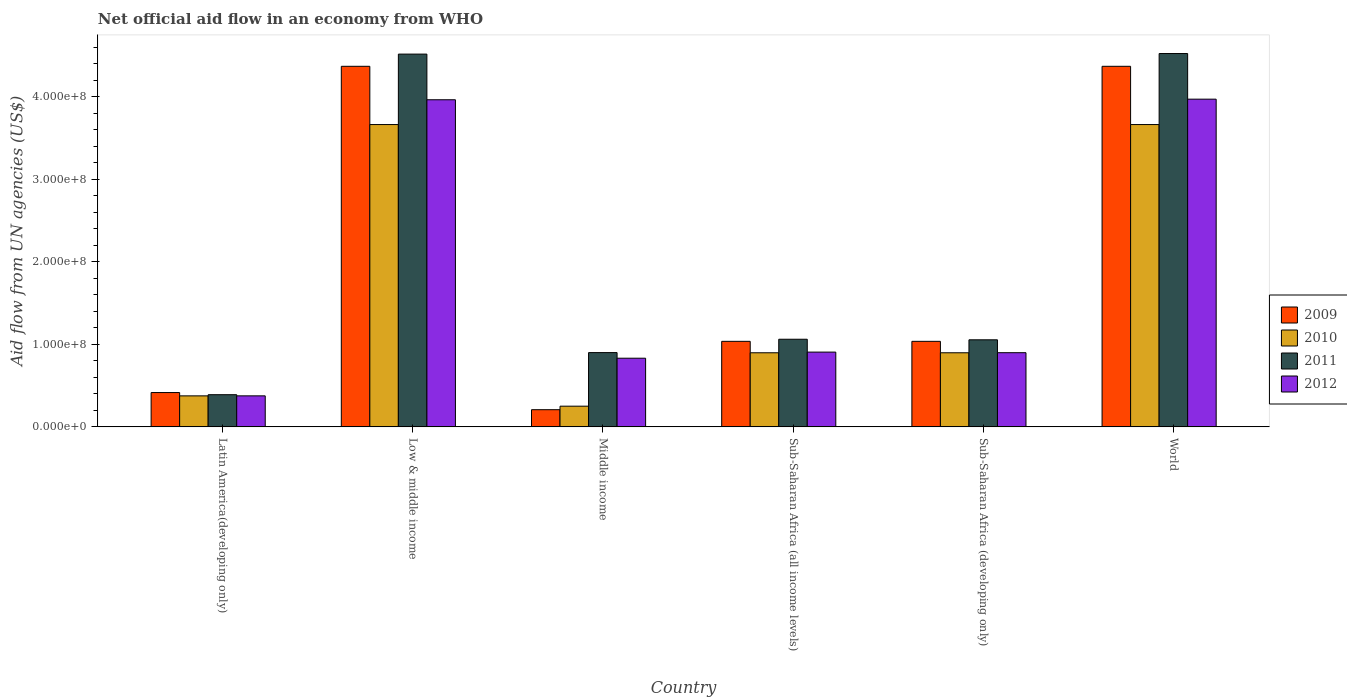How many different coloured bars are there?
Offer a very short reply. 4. Are the number of bars per tick equal to the number of legend labels?
Offer a terse response. Yes. What is the label of the 4th group of bars from the left?
Offer a very short reply. Sub-Saharan Africa (all income levels). What is the net official aid flow in 2010 in Middle income?
Keep it short and to the point. 2.51e+07. Across all countries, what is the maximum net official aid flow in 2010?
Give a very brief answer. 3.66e+08. Across all countries, what is the minimum net official aid flow in 2011?
Your answer should be very brief. 3.90e+07. In which country was the net official aid flow in 2010 minimum?
Ensure brevity in your answer.  Middle income. What is the total net official aid flow in 2012 in the graph?
Provide a short and direct response. 1.09e+09. What is the difference between the net official aid flow in 2009 in Middle income and that in World?
Provide a short and direct response. -4.16e+08. What is the difference between the net official aid flow in 2010 in Middle income and the net official aid flow in 2012 in Sub-Saharan Africa (all income levels)?
Give a very brief answer. -6.55e+07. What is the average net official aid flow in 2009 per country?
Offer a terse response. 1.91e+08. What is the difference between the net official aid flow of/in 2011 and net official aid flow of/in 2009 in Sub-Saharan Africa (developing only)?
Your response must be concise. 1.86e+06. In how many countries, is the net official aid flow in 2009 greater than 40000000 US$?
Provide a succinct answer. 5. What is the ratio of the net official aid flow in 2012 in Middle income to that in Sub-Saharan Africa (developing only)?
Offer a terse response. 0.93. Is the net official aid flow in 2012 in Middle income less than that in Sub-Saharan Africa (all income levels)?
Offer a very short reply. Yes. Is the difference between the net official aid flow in 2011 in Low & middle income and Sub-Saharan Africa (developing only) greater than the difference between the net official aid flow in 2009 in Low & middle income and Sub-Saharan Africa (developing only)?
Ensure brevity in your answer.  Yes. What is the difference between the highest and the second highest net official aid flow in 2010?
Your answer should be compact. 2.76e+08. What is the difference between the highest and the lowest net official aid flow in 2009?
Your response must be concise. 4.16e+08. What does the 1st bar from the left in Latin America(developing only) represents?
Provide a short and direct response. 2009. Are all the bars in the graph horizontal?
Ensure brevity in your answer.  No. Are the values on the major ticks of Y-axis written in scientific E-notation?
Provide a short and direct response. Yes. Does the graph contain grids?
Keep it short and to the point. No. What is the title of the graph?
Provide a short and direct response. Net official aid flow in an economy from WHO. What is the label or title of the X-axis?
Ensure brevity in your answer.  Country. What is the label or title of the Y-axis?
Provide a short and direct response. Aid flow from UN agencies (US$). What is the Aid flow from UN agencies (US$) of 2009 in Latin America(developing only)?
Ensure brevity in your answer.  4.16e+07. What is the Aid flow from UN agencies (US$) of 2010 in Latin America(developing only)?
Provide a short and direct response. 3.76e+07. What is the Aid flow from UN agencies (US$) of 2011 in Latin America(developing only)?
Offer a terse response. 3.90e+07. What is the Aid flow from UN agencies (US$) of 2012 in Latin America(developing only)?
Your response must be concise. 3.76e+07. What is the Aid flow from UN agencies (US$) of 2009 in Low & middle income?
Offer a very short reply. 4.37e+08. What is the Aid flow from UN agencies (US$) of 2010 in Low & middle income?
Give a very brief answer. 3.66e+08. What is the Aid flow from UN agencies (US$) in 2011 in Low & middle income?
Give a very brief answer. 4.52e+08. What is the Aid flow from UN agencies (US$) of 2012 in Low & middle income?
Provide a short and direct response. 3.96e+08. What is the Aid flow from UN agencies (US$) of 2009 in Middle income?
Provide a short and direct response. 2.08e+07. What is the Aid flow from UN agencies (US$) of 2010 in Middle income?
Your response must be concise. 2.51e+07. What is the Aid flow from UN agencies (US$) in 2011 in Middle income?
Offer a very short reply. 9.00e+07. What is the Aid flow from UN agencies (US$) of 2012 in Middle income?
Make the answer very short. 8.32e+07. What is the Aid flow from UN agencies (US$) in 2009 in Sub-Saharan Africa (all income levels)?
Make the answer very short. 1.04e+08. What is the Aid flow from UN agencies (US$) of 2010 in Sub-Saharan Africa (all income levels)?
Make the answer very short. 8.98e+07. What is the Aid flow from UN agencies (US$) of 2011 in Sub-Saharan Africa (all income levels)?
Your answer should be compact. 1.06e+08. What is the Aid flow from UN agencies (US$) in 2012 in Sub-Saharan Africa (all income levels)?
Your answer should be compact. 9.06e+07. What is the Aid flow from UN agencies (US$) in 2009 in Sub-Saharan Africa (developing only)?
Your response must be concise. 1.04e+08. What is the Aid flow from UN agencies (US$) of 2010 in Sub-Saharan Africa (developing only)?
Provide a short and direct response. 8.98e+07. What is the Aid flow from UN agencies (US$) of 2011 in Sub-Saharan Africa (developing only)?
Your answer should be compact. 1.05e+08. What is the Aid flow from UN agencies (US$) of 2012 in Sub-Saharan Africa (developing only)?
Give a very brief answer. 8.98e+07. What is the Aid flow from UN agencies (US$) in 2009 in World?
Your response must be concise. 4.37e+08. What is the Aid flow from UN agencies (US$) of 2010 in World?
Keep it short and to the point. 3.66e+08. What is the Aid flow from UN agencies (US$) in 2011 in World?
Ensure brevity in your answer.  4.52e+08. What is the Aid flow from UN agencies (US$) in 2012 in World?
Give a very brief answer. 3.97e+08. Across all countries, what is the maximum Aid flow from UN agencies (US$) of 2009?
Provide a short and direct response. 4.37e+08. Across all countries, what is the maximum Aid flow from UN agencies (US$) of 2010?
Provide a short and direct response. 3.66e+08. Across all countries, what is the maximum Aid flow from UN agencies (US$) of 2011?
Keep it short and to the point. 4.52e+08. Across all countries, what is the maximum Aid flow from UN agencies (US$) of 2012?
Give a very brief answer. 3.97e+08. Across all countries, what is the minimum Aid flow from UN agencies (US$) in 2009?
Provide a succinct answer. 2.08e+07. Across all countries, what is the minimum Aid flow from UN agencies (US$) of 2010?
Your response must be concise. 2.51e+07. Across all countries, what is the minimum Aid flow from UN agencies (US$) of 2011?
Your answer should be very brief. 3.90e+07. Across all countries, what is the minimum Aid flow from UN agencies (US$) in 2012?
Offer a very short reply. 3.76e+07. What is the total Aid flow from UN agencies (US$) of 2009 in the graph?
Ensure brevity in your answer.  1.14e+09. What is the total Aid flow from UN agencies (US$) in 2010 in the graph?
Provide a short and direct response. 9.75e+08. What is the total Aid flow from UN agencies (US$) of 2011 in the graph?
Offer a very short reply. 1.24e+09. What is the total Aid flow from UN agencies (US$) of 2012 in the graph?
Your response must be concise. 1.09e+09. What is the difference between the Aid flow from UN agencies (US$) of 2009 in Latin America(developing only) and that in Low & middle income?
Provide a short and direct response. -3.95e+08. What is the difference between the Aid flow from UN agencies (US$) of 2010 in Latin America(developing only) and that in Low & middle income?
Your response must be concise. -3.29e+08. What is the difference between the Aid flow from UN agencies (US$) in 2011 in Latin America(developing only) and that in Low & middle income?
Your answer should be compact. -4.13e+08. What is the difference between the Aid flow from UN agencies (US$) in 2012 in Latin America(developing only) and that in Low & middle income?
Offer a terse response. -3.59e+08. What is the difference between the Aid flow from UN agencies (US$) in 2009 in Latin America(developing only) and that in Middle income?
Your answer should be very brief. 2.08e+07. What is the difference between the Aid flow from UN agencies (US$) in 2010 in Latin America(developing only) and that in Middle income?
Offer a terse response. 1.25e+07. What is the difference between the Aid flow from UN agencies (US$) in 2011 in Latin America(developing only) and that in Middle income?
Provide a succinct answer. -5.10e+07. What is the difference between the Aid flow from UN agencies (US$) of 2012 in Latin America(developing only) and that in Middle income?
Your answer should be very brief. -4.56e+07. What is the difference between the Aid flow from UN agencies (US$) of 2009 in Latin America(developing only) and that in Sub-Saharan Africa (all income levels)?
Provide a short and direct response. -6.20e+07. What is the difference between the Aid flow from UN agencies (US$) in 2010 in Latin America(developing only) and that in Sub-Saharan Africa (all income levels)?
Make the answer very short. -5.22e+07. What is the difference between the Aid flow from UN agencies (US$) in 2011 in Latin America(developing only) and that in Sub-Saharan Africa (all income levels)?
Keep it short and to the point. -6.72e+07. What is the difference between the Aid flow from UN agencies (US$) in 2012 in Latin America(developing only) and that in Sub-Saharan Africa (all income levels)?
Keep it short and to the point. -5.30e+07. What is the difference between the Aid flow from UN agencies (US$) in 2009 in Latin America(developing only) and that in Sub-Saharan Africa (developing only)?
Provide a short and direct response. -6.20e+07. What is the difference between the Aid flow from UN agencies (US$) in 2010 in Latin America(developing only) and that in Sub-Saharan Africa (developing only)?
Provide a succinct answer. -5.22e+07. What is the difference between the Aid flow from UN agencies (US$) in 2011 in Latin America(developing only) and that in Sub-Saharan Africa (developing only)?
Make the answer very short. -6.65e+07. What is the difference between the Aid flow from UN agencies (US$) of 2012 in Latin America(developing only) and that in Sub-Saharan Africa (developing only)?
Provide a succinct answer. -5.23e+07. What is the difference between the Aid flow from UN agencies (US$) in 2009 in Latin America(developing only) and that in World?
Provide a succinct answer. -3.95e+08. What is the difference between the Aid flow from UN agencies (US$) of 2010 in Latin America(developing only) and that in World?
Your response must be concise. -3.29e+08. What is the difference between the Aid flow from UN agencies (US$) in 2011 in Latin America(developing only) and that in World?
Offer a very short reply. -4.13e+08. What is the difference between the Aid flow from UN agencies (US$) in 2012 in Latin America(developing only) and that in World?
Your answer should be very brief. -3.59e+08. What is the difference between the Aid flow from UN agencies (US$) of 2009 in Low & middle income and that in Middle income?
Offer a terse response. 4.16e+08. What is the difference between the Aid flow from UN agencies (US$) in 2010 in Low & middle income and that in Middle income?
Your response must be concise. 3.41e+08. What is the difference between the Aid flow from UN agencies (US$) of 2011 in Low & middle income and that in Middle income?
Provide a short and direct response. 3.62e+08. What is the difference between the Aid flow from UN agencies (US$) of 2012 in Low & middle income and that in Middle income?
Ensure brevity in your answer.  3.13e+08. What is the difference between the Aid flow from UN agencies (US$) in 2009 in Low & middle income and that in Sub-Saharan Africa (all income levels)?
Your answer should be very brief. 3.33e+08. What is the difference between the Aid flow from UN agencies (US$) in 2010 in Low & middle income and that in Sub-Saharan Africa (all income levels)?
Give a very brief answer. 2.76e+08. What is the difference between the Aid flow from UN agencies (US$) of 2011 in Low & middle income and that in Sub-Saharan Africa (all income levels)?
Ensure brevity in your answer.  3.45e+08. What is the difference between the Aid flow from UN agencies (US$) of 2012 in Low & middle income and that in Sub-Saharan Africa (all income levels)?
Give a very brief answer. 3.06e+08. What is the difference between the Aid flow from UN agencies (US$) in 2009 in Low & middle income and that in Sub-Saharan Africa (developing only)?
Provide a short and direct response. 3.33e+08. What is the difference between the Aid flow from UN agencies (US$) in 2010 in Low & middle income and that in Sub-Saharan Africa (developing only)?
Make the answer very short. 2.76e+08. What is the difference between the Aid flow from UN agencies (US$) of 2011 in Low & middle income and that in Sub-Saharan Africa (developing only)?
Provide a succinct answer. 3.46e+08. What is the difference between the Aid flow from UN agencies (US$) in 2012 in Low & middle income and that in Sub-Saharan Africa (developing only)?
Your response must be concise. 3.06e+08. What is the difference between the Aid flow from UN agencies (US$) of 2011 in Low & middle income and that in World?
Your response must be concise. -6.70e+05. What is the difference between the Aid flow from UN agencies (US$) in 2012 in Low & middle income and that in World?
Give a very brief answer. -7.20e+05. What is the difference between the Aid flow from UN agencies (US$) of 2009 in Middle income and that in Sub-Saharan Africa (all income levels)?
Your answer should be very brief. -8.28e+07. What is the difference between the Aid flow from UN agencies (US$) in 2010 in Middle income and that in Sub-Saharan Africa (all income levels)?
Make the answer very short. -6.47e+07. What is the difference between the Aid flow from UN agencies (US$) in 2011 in Middle income and that in Sub-Saharan Africa (all income levels)?
Your response must be concise. -1.62e+07. What is the difference between the Aid flow from UN agencies (US$) in 2012 in Middle income and that in Sub-Saharan Africa (all income levels)?
Give a very brief answer. -7.39e+06. What is the difference between the Aid flow from UN agencies (US$) in 2009 in Middle income and that in Sub-Saharan Africa (developing only)?
Provide a short and direct response. -8.28e+07. What is the difference between the Aid flow from UN agencies (US$) of 2010 in Middle income and that in Sub-Saharan Africa (developing only)?
Keep it short and to the point. -6.47e+07. What is the difference between the Aid flow from UN agencies (US$) of 2011 in Middle income and that in Sub-Saharan Africa (developing only)?
Provide a short and direct response. -1.55e+07. What is the difference between the Aid flow from UN agencies (US$) in 2012 in Middle income and that in Sub-Saharan Africa (developing only)?
Provide a short and direct response. -6.67e+06. What is the difference between the Aid flow from UN agencies (US$) in 2009 in Middle income and that in World?
Keep it short and to the point. -4.16e+08. What is the difference between the Aid flow from UN agencies (US$) in 2010 in Middle income and that in World?
Provide a short and direct response. -3.41e+08. What is the difference between the Aid flow from UN agencies (US$) of 2011 in Middle income and that in World?
Give a very brief answer. -3.62e+08. What is the difference between the Aid flow from UN agencies (US$) of 2012 in Middle income and that in World?
Your response must be concise. -3.14e+08. What is the difference between the Aid flow from UN agencies (US$) in 2009 in Sub-Saharan Africa (all income levels) and that in Sub-Saharan Africa (developing only)?
Ensure brevity in your answer.  0. What is the difference between the Aid flow from UN agencies (US$) in 2010 in Sub-Saharan Africa (all income levels) and that in Sub-Saharan Africa (developing only)?
Provide a succinct answer. 0. What is the difference between the Aid flow from UN agencies (US$) of 2011 in Sub-Saharan Africa (all income levels) and that in Sub-Saharan Africa (developing only)?
Ensure brevity in your answer.  6.70e+05. What is the difference between the Aid flow from UN agencies (US$) in 2012 in Sub-Saharan Africa (all income levels) and that in Sub-Saharan Africa (developing only)?
Offer a very short reply. 7.20e+05. What is the difference between the Aid flow from UN agencies (US$) of 2009 in Sub-Saharan Africa (all income levels) and that in World?
Your answer should be compact. -3.33e+08. What is the difference between the Aid flow from UN agencies (US$) in 2010 in Sub-Saharan Africa (all income levels) and that in World?
Offer a terse response. -2.76e+08. What is the difference between the Aid flow from UN agencies (US$) in 2011 in Sub-Saharan Africa (all income levels) and that in World?
Your response must be concise. -3.46e+08. What is the difference between the Aid flow from UN agencies (US$) in 2012 in Sub-Saharan Africa (all income levels) and that in World?
Ensure brevity in your answer.  -3.06e+08. What is the difference between the Aid flow from UN agencies (US$) of 2009 in Sub-Saharan Africa (developing only) and that in World?
Your answer should be very brief. -3.33e+08. What is the difference between the Aid flow from UN agencies (US$) of 2010 in Sub-Saharan Africa (developing only) and that in World?
Keep it short and to the point. -2.76e+08. What is the difference between the Aid flow from UN agencies (US$) of 2011 in Sub-Saharan Africa (developing only) and that in World?
Make the answer very short. -3.47e+08. What is the difference between the Aid flow from UN agencies (US$) of 2012 in Sub-Saharan Africa (developing only) and that in World?
Your answer should be very brief. -3.07e+08. What is the difference between the Aid flow from UN agencies (US$) in 2009 in Latin America(developing only) and the Aid flow from UN agencies (US$) in 2010 in Low & middle income?
Provide a succinct answer. -3.25e+08. What is the difference between the Aid flow from UN agencies (US$) in 2009 in Latin America(developing only) and the Aid flow from UN agencies (US$) in 2011 in Low & middle income?
Your response must be concise. -4.10e+08. What is the difference between the Aid flow from UN agencies (US$) in 2009 in Latin America(developing only) and the Aid flow from UN agencies (US$) in 2012 in Low & middle income?
Your response must be concise. -3.55e+08. What is the difference between the Aid flow from UN agencies (US$) in 2010 in Latin America(developing only) and the Aid flow from UN agencies (US$) in 2011 in Low & middle income?
Offer a very short reply. -4.14e+08. What is the difference between the Aid flow from UN agencies (US$) in 2010 in Latin America(developing only) and the Aid flow from UN agencies (US$) in 2012 in Low & middle income?
Offer a very short reply. -3.59e+08. What is the difference between the Aid flow from UN agencies (US$) of 2011 in Latin America(developing only) and the Aid flow from UN agencies (US$) of 2012 in Low & middle income?
Ensure brevity in your answer.  -3.57e+08. What is the difference between the Aid flow from UN agencies (US$) in 2009 in Latin America(developing only) and the Aid flow from UN agencies (US$) in 2010 in Middle income?
Provide a succinct answer. 1.65e+07. What is the difference between the Aid flow from UN agencies (US$) of 2009 in Latin America(developing only) and the Aid flow from UN agencies (US$) of 2011 in Middle income?
Your answer should be compact. -4.84e+07. What is the difference between the Aid flow from UN agencies (US$) in 2009 in Latin America(developing only) and the Aid flow from UN agencies (US$) in 2012 in Middle income?
Offer a very short reply. -4.16e+07. What is the difference between the Aid flow from UN agencies (US$) in 2010 in Latin America(developing only) and the Aid flow from UN agencies (US$) in 2011 in Middle income?
Your answer should be very brief. -5.24e+07. What is the difference between the Aid flow from UN agencies (US$) in 2010 in Latin America(developing only) and the Aid flow from UN agencies (US$) in 2012 in Middle income?
Keep it short and to the point. -4.56e+07. What is the difference between the Aid flow from UN agencies (US$) of 2011 in Latin America(developing only) and the Aid flow from UN agencies (US$) of 2012 in Middle income?
Offer a terse response. -4.42e+07. What is the difference between the Aid flow from UN agencies (US$) of 2009 in Latin America(developing only) and the Aid flow from UN agencies (US$) of 2010 in Sub-Saharan Africa (all income levels)?
Make the answer very short. -4.82e+07. What is the difference between the Aid flow from UN agencies (US$) of 2009 in Latin America(developing only) and the Aid flow from UN agencies (US$) of 2011 in Sub-Saharan Africa (all income levels)?
Your answer should be very brief. -6.46e+07. What is the difference between the Aid flow from UN agencies (US$) of 2009 in Latin America(developing only) and the Aid flow from UN agencies (US$) of 2012 in Sub-Saharan Africa (all income levels)?
Give a very brief answer. -4.90e+07. What is the difference between the Aid flow from UN agencies (US$) in 2010 in Latin America(developing only) and the Aid flow from UN agencies (US$) in 2011 in Sub-Saharan Africa (all income levels)?
Your answer should be compact. -6.86e+07. What is the difference between the Aid flow from UN agencies (US$) of 2010 in Latin America(developing only) and the Aid flow from UN agencies (US$) of 2012 in Sub-Saharan Africa (all income levels)?
Offer a very short reply. -5.30e+07. What is the difference between the Aid flow from UN agencies (US$) of 2011 in Latin America(developing only) and the Aid flow from UN agencies (US$) of 2012 in Sub-Saharan Africa (all income levels)?
Make the answer very short. -5.16e+07. What is the difference between the Aid flow from UN agencies (US$) in 2009 in Latin America(developing only) and the Aid flow from UN agencies (US$) in 2010 in Sub-Saharan Africa (developing only)?
Your response must be concise. -4.82e+07. What is the difference between the Aid flow from UN agencies (US$) in 2009 in Latin America(developing only) and the Aid flow from UN agencies (US$) in 2011 in Sub-Saharan Africa (developing only)?
Give a very brief answer. -6.39e+07. What is the difference between the Aid flow from UN agencies (US$) in 2009 in Latin America(developing only) and the Aid flow from UN agencies (US$) in 2012 in Sub-Saharan Africa (developing only)?
Provide a short and direct response. -4.83e+07. What is the difference between the Aid flow from UN agencies (US$) of 2010 in Latin America(developing only) and the Aid flow from UN agencies (US$) of 2011 in Sub-Saharan Africa (developing only)?
Make the answer very short. -6.79e+07. What is the difference between the Aid flow from UN agencies (US$) of 2010 in Latin America(developing only) and the Aid flow from UN agencies (US$) of 2012 in Sub-Saharan Africa (developing only)?
Ensure brevity in your answer.  -5.23e+07. What is the difference between the Aid flow from UN agencies (US$) of 2011 in Latin America(developing only) and the Aid flow from UN agencies (US$) of 2012 in Sub-Saharan Africa (developing only)?
Offer a terse response. -5.09e+07. What is the difference between the Aid flow from UN agencies (US$) in 2009 in Latin America(developing only) and the Aid flow from UN agencies (US$) in 2010 in World?
Provide a succinct answer. -3.25e+08. What is the difference between the Aid flow from UN agencies (US$) of 2009 in Latin America(developing only) and the Aid flow from UN agencies (US$) of 2011 in World?
Ensure brevity in your answer.  -4.11e+08. What is the difference between the Aid flow from UN agencies (US$) of 2009 in Latin America(developing only) and the Aid flow from UN agencies (US$) of 2012 in World?
Ensure brevity in your answer.  -3.55e+08. What is the difference between the Aid flow from UN agencies (US$) of 2010 in Latin America(developing only) and the Aid flow from UN agencies (US$) of 2011 in World?
Your answer should be compact. -4.15e+08. What is the difference between the Aid flow from UN agencies (US$) of 2010 in Latin America(developing only) and the Aid flow from UN agencies (US$) of 2012 in World?
Your answer should be very brief. -3.59e+08. What is the difference between the Aid flow from UN agencies (US$) in 2011 in Latin America(developing only) and the Aid flow from UN agencies (US$) in 2012 in World?
Offer a very short reply. -3.58e+08. What is the difference between the Aid flow from UN agencies (US$) of 2009 in Low & middle income and the Aid flow from UN agencies (US$) of 2010 in Middle income?
Give a very brief answer. 4.12e+08. What is the difference between the Aid flow from UN agencies (US$) of 2009 in Low & middle income and the Aid flow from UN agencies (US$) of 2011 in Middle income?
Provide a short and direct response. 3.47e+08. What is the difference between the Aid flow from UN agencies (US$) in 2009 in Low & middle income and the Aid flow from UN agencies (US$) in 2012 in Middle income?
Ensure brevity in your answer.  3.54e+08. What is the difference between the Aid flow from UN agencies (US$) of 2010 in Low & middle income and the Aid flow from UN agencies (US$) of 2011 in Middle income?
Ensure brevity in your answer.  2.76e+08. What is the difference between the Aid flow from UN agencies (US$) in 2010 in Low & middle income and the Aid flow from UN agencies (US$) in 2012 in Middle income?
Give a very brief answer. 2.83e+08. What is the difference between the Aid flow from UN agencies (US$) of 2011 in Low & middle income and the Aid flow from UN agencies (US$) of 2012 in Middle income?
Your answer should be very brief. 3.68e+08. What is the difference between the Aid flow from UN agencies (US$) of 2009 in Low & middle income and the Aid flow from UN agencies (US$) of 2010 in Sub-Saharan Africa (all income levels)?
Provide a succinct answer. 3.47e+08. What is the difference between the Aid flow from UN agencies (US$) of 2009 in Low & middle income and the Aid flow from UN agencies (US$) of 2011 in Sub-Saharan Africa (all income levels)?
Offer a terse response. 3.31e+08. What is the difference between the Aid flow from UN agencies (US$) in 2009 in Low & middle income and the Aid flow from UN agencies (US$) in 2012 in Sub-Saharan Africa (all income levels)?
Keep it short and to the point. 3.46e+08. What is the difference between the Aid flow from UN agencies (US$) of 2010 in Low & middle income and the Aid flow from UN agencies (US$) of 2011 in Sub-Saharan Africa (all income levels)?
Provide a succinct answer. 2.60e+08. What is the difference between the Aid flow from UN agencies (US$) in 2010 in Low & middle income and the Aid flow from UN agencies (US$) in 2012 in Sub-Saharan Africa (all income levels)?
Ensure brevity in your answer.  2.76e+08. What is the difference between the Aid flow from UN agencies (US$) of 2011 in Low & middle income and the Aid flow from UN agencies (US$) of 2012 in Sub-Saharan Africa (all income levels)?
Offer a very short reply. 3.61e+08. What is the difference between the Aid flow from UN agencies (US$) of 2009 in Low & middle income and the Aid flow from UN agencies (US$) of 2010 in Sub-Saharan Africa (developing only)?
Give a very brief answer. 3.47e+08. What is the difference between the Aid flow from UN agencies (US$) of 2009 in Low & middle income and the Aid flow from UN agencies (US$) of 2011 in Sub-Saharan Africa (developing only)?
Keep it short and to the point. 3.31e+08. What is the difference between the Aid flow from UN agencies (US$) of 2009 in Low & middle income and the Aid flow from UN agencies (US$) of 2012 in Sub-Saharan Africa (developing only)?
Offer a terse response. 3.47e+08. What is the difference between the Aid flow from UN agencies (US$) in 2010 in Low & middle income and the Aid flow from UN agencies (US$) in 2011 in Sub-Saharan Africa (developing only)?
Make the answer very short. 2.61e+08. What is the difference between the Aid flow from UN agencies (US$) of 2010 in Low & middle income and the Aid flow from UN agencies (US$) of 2012 in Sub-Saharan Africa (developing only)?
Ensure brevity in your answer.  2.76e+08. What is the difference between the Aid flow from UN agencies (US$) of 2011 in Low & middle income and the Aid flow from UN agencies (US$) of 2012 in Sub-Saharan Africa (developing only)?
Provide a short and direct response. 3.62e+08. What is the difference between the Aid flow from UN agencies (US$) of 2009 in Low & middle income and the Aid flow from UN agencies (US$) of 2010 in World?
Make the answer very short. 7.06e+07. What is the difference between the Aid flow from UN agencies (US$) of 2009 in Low & middle income and the Aid flow from UN agencies (US$) of 2011 in World?
Give a very brief answer. -1.55e+07. What is the difference between the Aid flow from UN agencies (US$) of 2009 in Low & middle income and the Aid flow from UN agencies (US$) of 2012 in World?
Your answer should be compact. 3.98e+07. What is the difference between the Aid flow from UN agencies (US$) in 2010 in Low & middle income and the Aid flow from UN agencies (US$) in 2011 in World?
Offer a very short reply. -8.60e+07. What is the difference between the Aid flow from UN agencies (US$) in 2010 in Low & middle income and the Aid flow from UN agencies (US$) in 2012 in World?
Your answer should be very brief. -3.08e+07. What is the difference between the Aid flow from UN agencies (US$) in 2011 in Low & middle income and the Aid flow from UN agencies (US$) in 2012 in World?
Keep it short and to the point. 5.46e+07. What is the difference between the Aid flow from UN agencies (US$) in 2009 in Middle income and the Aid flow from UN agencies (US$) in 2010 in Sub-Saharan Africa (all income levels)?
Your response must be concise. -6.90e+07. What is the difference between the Aid flow from UN agencies (US$) of 2009 in Middle income and the Aid flow from UN agencies (US$) of 2011 in Sub-Saharan Africa (all income levels)?
Make the answer very short. -8.54e+07. What is the difference between the Aid flow from UN agencies (US$) in 2009 in Middle income and the Aid flow from UN agencies (US$) in 2012 in Sub-Saharan Africa (all income levels)?
Give a very brief answer. -6.98e+07. What is the difference between the Aid flow from UN agencies (US$) in 2010 in Middle income and the Aid flow from UN agencies (US$) in 2011 in Sub-Saharan Africa (all income levels)?
Provide a short and direct response. -8.11e+07. What is the difference between the Aid flow from UN agencies (US$) in 2010 in Middle income and the Aid flow from UN agencies (US$) in 2012 in Sub-Saharan Africa (all income levels)?
Give a very brief answer. -6.55e+07. What is the difference between the Aid flow from UN agencies (US$) of 2011 in Middle income and the Aid flow from UN agencies (US$) of 2012 in Sub-Saharan Africa (all income levels)?
Your answer should be compact. -5.90e+05. What is the difference between the Aid flow from UN agencies (US$) in 2009 in Middle income and the Aid flow from UN agencies (US$) in 2010 in Sub-Saharan Africa (developing only)?
Keep it short and to the point. -6.90e+07. What is the difference between the Aid flow from UN agencies (US$) in 2009 in Middle income and the Aid flow from UN agencies (US$) in 2011 in Sub-Saharan Africa (developing only)?
Provide a succinct answer. -8.47e+07. What is the difference between the Aid flow from UN agencies (US$) of 2009 in Middle income and the Aid flow from UN agencies (US$) of 2012 in Sub-Saharan Africa (developing only)?
Your response must be concise. -6.90e+07. What is the difference between the Aid flow from UN agencies (US$) in 2010 in Middle income and the Aid flow from UN agencies (US$) in 2011 in Sub-Saharan Africa (developing only)?
Make the answer very short. -8.04e+07. What is the difference between the Aid flow from UN agencies (US$) in 2010 in Middle income and the Aid flow from UN agencies (US$) in 2012 in Sub-Saharan Africa (developing only)?
Keep it short and to the point. -6.48e+07. What is the difference between the Aid flow from UN agencies (US$) in 2009 in Middle income and the Aid flow from UN agencies (US$) in 2010 in World?
Give a very brief answer. -3.45e+08. What is the difference between the Aid flow from UN agencies (US$) of 2009 in Middle income and the Aid flow from UN agencies (US$) of 2011 in World?
Make the answer very short. -4.31e+08. What is the difference between the Aid flow from UN agencies (US$) of 2009 in Middle income and the Aid flow from UN agencies (US$) of 2012 in World?
Provide a succinct answer. -3.76e+08. What is the difference between the Aid flow from UN agencies (US$) of 2010 in Middle income and the Aid flow from UN agencies (US$) of 2011 in World?
Offer a very short reply. -4.27e+08. What is the difference between the Aid flow from UN agencies (US$) of 2010 in Middle income and the Aid flow from UN agencies (US$) of 2012 in World?
Give a very brief answer. -3.72e+08. What is the difference between the Aid flow from UN agencies (US$) in 2011 in Middle income and the Aid flow from UN agencies (US$) in 2012 in World?
Keep it short and to the point. -3.07e+08. What is the difference between the Aid flow from UN agencies (US$) in 2009 in Sub-Saharan Africa (all income levels) and the Aid flow from UN agencies (US$) in 2010 in Sub-Saharan Africa (developing only)?
Offer a terse response. 1.39e+07. What is the difference between the Aid flow from UN agencies (US$) in 2009 in Sub-Saharan Africa (all income levels) and the Aid flow from UN agencies (US$) in 2011 in Sub-Saharan Africa (developing only)?
Your answer should be compact. -1.86e+06. What is the difference between the Aid flow from UN agencies (US$) in 2009 in Sub-Saharan Africa (all income levels) and the Aid flow from UN agencies (US$) in 2012 in Sub-Saharan Africa (developing only)?
Ensure brevity in your answer.  1.38e+07. What is the difference between the Aid flow from UN agencies (US$) of 2010 in Sub-Saharan Africa (all income levels) and the Aid flow from UN agencies (US$) of 2011 in Sub-Saharan Africa (developing only)?
Give a very brief answer. -1.57e+07. What is the difference between the Aid flow from UN agencies (US$) in 2010 in Sub-Saharan Africa (all income levels) and the Aid flow from UN agencies (US$) in 2012 in Sub-Saharan Africa (developing only)?
Make the answer very short. -9.00e+04. What is the difference between the Aid flow from UN agencies (US$) in 2011 in Sub-Saharan Africa (all income levels) and the Aid flow from UN agencies (US$) in 2012 in Sub-Saharan Africa (developing only)?
Your response must be concise. 1.63e+07. What is the difference between the Aid flow from UN agencies (US$) of 2009 in Sub-Saharan Africa (all income levels) and the Aid flow from UN agencies (US$) of 2010 in World?
Offer a terse response. -2.63e+08. What is the difference between the Aid flow from UN agencies (US$) of 2009 in Sub-Saharan Africa (all income levels) and the Aid flow from UN agencies (US$) of 2011 in World?
Offer a terse response. -3.49e+08. What is the difference between the Aid flow from UN agencies (US$) in 2009 in Sub-Saharan Africa (all income levels) and the Aid flow from UN agencies (US$) in 2012 in World?
Your response must be concise. -2.93e+08. What is the difference between the Aid flow from UN agencies (US$) of 2010 in Sub-Saharan Africa (all income levels) and the Aid flow from UN agencies (US$) of 2011 in World?
Offer a very short reply. -3.62e+08. What is the difference between the Aid flow from UN agencies (US$) of 2010 in Sub-Saharan Africa (all income levels) and the Aid flow from UN agencies (US$) of 2012 in World?
Ensure brevity in your answer.  -3.07e+08. What is the difference between the Aid flow from UN agencies (US$) of 2011 in Sub-Saharan Africa (all income levels) and the Aid flow from UN agencies (US$) of 2012 in World?
Provide a succinct answer. -2.91e+08. What is the difference between the Aid flow from UN agencies (US$) of 2009 in Sub-Saharan Africa (developing only) and the Aid flow from UN agencies (US$) of 2010 in World?
Your answer should be very brief. -2.63e+08. What is the difference between the Aid flow from UN agencies (US$) in 2009 in Sub-Saharan Africa (developing only) and the Aid flow from UN agencies (US$) in 2011 in World?
Ensure brevity in your answer.  -3.49e+08. What is the difference between the Aid flow from UN agencies (US$) in 2009 in Sub-Saharan Africa (developing only) and the Aid flow from UN agencies (US$) in 2012 in World?
Your answer should be compact. -2.93e+08. What is the difference between the Aid flow from UN agencies (US$) in 2010 in Sub-Saharan Africa (developing only) and the Aid flow from UN agencies (US$) in 2011 in World?
Give a very brief answer. -3.62e+08. What is the difference between the Aid flow from UN agencies (US$) in 2010 in Sub-Saharan Africa (developing only) and the Aid flow from UN agencies (US$) in 2012 in World?
Ensure brevity in your answer.  -3.07e+08. What is the difference between the Aid flow from UN agencies (US$) of 2011 in Sub-Saharan Africa (developing only) and the Aid flow from UN agencies (US$) of 2012 in World?
Provide a short and direct response. -2.92e+08. What is the average Aid flow from UN agencies (US$) in 2009 per country?
Offer a terse response. 1.91e+08. What is the average Aid flow from UN agencies (US$) in 2010 per country?
Offer a terse response. 1.62e+08. What is the average Aid flow from UN agencies (US$) of 2011 per country?
Your response must be concise. 2.07e+08. What is the average Aid flow from UN agencies (US$) in 2012 per country?
Make the answer very short. 1.82e+08. What is the difference between the Aid flow from UN agencies (US$) of 2009 and Aid flow from UN agencies (US$) of 2010 in Latin America(developing only)?
Your response must be concise. 4.01e+06. What is the difference between the Aid flow from UN agencies (US$) of 2009 and Aid flow from UN agencies (US$) of 2011 in Latin America(developing only)?
Offer a very short reply. 2.59e+06. What is the difference between the Aid flow from UN agencies (US$) in 2009 and Aid flow from UN agencies (US$) in 2012 in Latin America(developing only)?
Ensure brevity in your answer.  3.99e+06. What is the difference between the Aid flow from UN agencies (US$) in 2010 and Aid flow from UN agencies (US$) in 2011 in Latin America(developing only)?
Your answer should be compact. -1.42e+06. What is the difference between the Aid flow from UN agencies (US$) of 2011 and Aid flow from UN agencies (US$) of 2012 in Latin America(developing only)?
Offer a very short reply. 1.40e+06. What is the difference between the Aid flow from UN agencies (US$) in 2009 and Aid flow from UN agencies (US$) in 2010 in Low & middle income?
Offer a very short reply. 7.06e+07. What is the difference between the Aid flow from UN agencies (US$) in 2009 and Aid flow from UN agencies (US$) in 2011 in Low & middle income?
Offer a very short reply. -1.48e+07. What is the difference between the Aid flow from UN agencies (US$) of 2009 and Aid flow from UN agencies (US$) of 2012 in Low & middle income?
Your answer should be compact. 4.05e+07. What is the difference between the Aid flow from UN agencies (US$) in 2010 and Aid flow from UN agencies (US$) in 2011 in Low & middle income?
Give a very brief answer. -8.54e+07. What is the difference between the Aid flow from UN agencies (US$) in 2010 and Aid flow from UN agencies (US$) in 2012 in Low & middle income?
Your answer should be very brief. -3.00e+07. What is the difference between the Aid flow from UN agencies (US$) of 2011 and Aid flow from UN agencies (US$) of 2012 in Low & middle income?
Your answer should be compact. 5.53e+07. What is the difference between the Aid flow from UN agencies (US$) in 2009 and Aid flow from UN agencies (US$) in 2010 in Middle income?
Give a very brief answer. -4.27e+06. What is the difference between the Aid flow from UN agencies (US$) of 2009 and Aid flow from UN agencies (US$) of 2011 in Middle income?
Ensure brevity in your answer.  -6.92e+07. What is the difference between the Aid flow from UN agencies (US$) of 2009 and Aid flow from UN agencies (US$) of 2012 in Middle income?
Your answer should be very brief. -6.24e+07. What is the difference between the Aid flow from UN agencies (US$) in 2010 and Aid flow from UN agencies (US$) in 2011 in Middle income?
Keep it short and to the point. -6.49e+07. What is the difference between the Aid flow from UN agencies (US$) in 2010 and Aid flow from UN agencies (US$) in 2012 in Middle income?
Give a very brief answer. -5.81e+07. What is the difference between the Aid flow from UN agencies (US$) of 2011 and Aid flow from UN agencies (US$) of 2012 in Middle income?
Give a very brief answer. 6.80e+06. What is the difference between the Aid flow from UN agencies (US$) in 2009 and Aid flow from UN agencies (US$) in 2010 in Sub-Saharan Africa (all income levels)?
Your answer should be compact. 1.39e+07. What is the difference between the Aid flow from UN agencies (US$) in 2009 and Aid flow from UN agencies (US$) in 2011 in Sub-Saharan Africa (all income levels)?
Your answer should be very brief. -2.53e+06. What is the difference between the Aid flow from UN agencies (US$) of 2009 and Aid flow from UN agencies (US$) of 2012 in Sub-Saharan Africa (all income levels)?
Your answer should be very brief. 1.30e+07. What is the difference between the Aid flow from UN agencies (US$) in 2010 and Aid flow from UN agencies (US$) in 2011 in Sub-Saharan Africa (all income levels)?
Your answer should be compact. -1.64e+07. What is the difference between the Aid flow from UN agencies (US$) of 2010 and Aid flow from UN agencies (US$) of 2012 in Sub-Saharan Africa (all income levels)?
Provide a succinct answer. -8.10e+05. What is the difference between the Aid flow from UN agencies (US$) in 2011 and Aid flow from UN agencies (US$) in 2012 in Sub-Saharan Africa (all income levels)?
Give a very brief answer. 1.56e+07. What is the difference between the Aid flow from UN agencies (US$) in 2009 and Aid flow from UN agencies (US$) in 2010 in Sub-Saharan Africa (developing only)?
Offer a terse response. 1.39e+07. What is the difference between the Aid flow from UN agencies (US$) of 2009 and Aid flow from UN agencies (US$) of 2011 in Sub-Saharan Africa (developing only)?
Keep it short and to the point. -1.86e+06. What is the difference between the Aid flow from UN agencies (US$) in 2009 and Aid flow from UN agencies (US$) in 2012 in Sub-Saharan Africa (developing only)?
Provide a short and direct response. 1.38e+07. What is the difference between the Aid flow from UN agencies (US$) of 2010 and Aid flow from UN agencies (US$) of 2011 in Sub-Saharan Africa (developing only)?
Provide a succinct answer. -1.57e+07. What is the difference between the Aid flow from UN agencies (US$) of 2010 and Aid flow from UN agencies (US$) of 2012 in Sub-Saharan Africa (developing only)?
Offer a terse response. -9.00e+04. What is the difference between the Aid flow from UN agencies (US$) of 2011 and Aid flow from UN agencies (US$) of 2012 in Sub-Saharan Africa (developing only)?
Give a very brief answer. 1.56e+07. What is the difference between the Aid flow from UN agencies (US$) of 2009 and Aid flow from UN agencies (US$) of 2010 in World?
Provide a short and direct response. 7.06e+07. What is the difference between the Aid flow from UN agencies (US$) of 2009 and Aid flow from UN agencies (US$) of 2011 in World?
Ensure brevity in your answer.  -1.55e+07. What is the difference between the Aid flow from UN agencies (US$) of 2009 and Aid flow from UN agencies (US$) of 2012 in World?
Offer a terse response. 3.98e+07. What is the difference between the Aid flow from UN agencies (US$) of 2010 and Aid flow from UN agencies (US$) of 2011 in World?
Offer a terse response. -8.60e+07. What is the difference between the Aid flow from UN agencies (US$) in 2010 and Aid flow from UN agencies (US$) in 2012 in World?
Provide a short and direct response. -3.08e+07. What is the difference between the Aid flow from UN agencies (US$) of 2011 and Aid flow from UN agencies (US$) of 2012 in World?
Ensure brevity in your answer.  5.53e+07. What is the ratio of the Aid flow from UN agencies (US$) of 2009 in Latin America(developing only) to that in Low & middle income?
Your response must be concise. 0.1. What is the ratio of the Aid flow from UN agencies (US$) of 2010 in Latin America(developing only) to that in Low & middle income?
Provide a short and direct response. 0.1. What is the ratio of the Aid flow from UN agencies (US$) of 2011 in Latin America(developing only) to that in Low & middle income?
Offer a terse response. 0.09. What is the ratio of the Aid flow from UN agencies (US$) in 2012 in Latin America(developing only) to that in Low & middle income?
Provide a short and direct response. 0.09. What is the ratio of the Aid flow from UN agencies (US$) in 2009 in Latin America(developing only) to that in Middle income?
Provide a succinct answer. 2. What is the ratio of the Aid flow from UN agencies (US$) of 2010 in Latin America(developing only) to that in Middle income?
Keep it short and to the point. 1.5. What is the ratio of the Aid flow from UN agencies (US$) of 2011 in Latin America(developing only) to that in Middle income?
Your answer should be compact. 0.43. What is the ratio of the Aid flow from UN agencies (US$) of 2012 in Latin America(developing only) to that in Middle income?
Ensure brevity in your answer.  0.45. What is the ratio of the Aid flow from UN agencies (US$) of 2009 in Latin America(developing only) to that in Sub-Saharan Africa (all income levels)?
Your answer should be compact. 0.4. What is the ratio of the Aid flow from UN agencies (US$) in 2010 in Latin America(developing only) to that in Sub-Saharan Africa (all income levels)?
Your answer should be compact. 0.42. What is the ratio of the Aid flow from UN agencies (US$) of 2011 in Latin America(developing only) to that in Sub-Saharan Africa (all income levels)?
Give a very brief answer. 0.37. What is the ratio of the Aid flow from UN agencies (US$) in 2012 in Latin America(developing only) to that in Sub-Saharan Africa (all income levels)?
Offer a very short reply. 0.41. What is the ratio of the Aid flow from UN agencies (US$) in 2009 in Latin America(developing only) to that in Sub-Saharan Africa (developing only)?
Your answer should be compact. 0.4. What is the ratio of the Aid flow from UN agencies (US$) in 2010 in Latin America(developing only) to that in Sub-Saharan Africa (developing only)?
Ensure brevity in your answer.  0.42. What is the ratio of the Aid flow from UN agencies (US$) in 2011 in Latin America(developing only) to that in Sub-Saharan Africa (developing only)?
Make the answer very short. 0.37. What is the ratio of the Aid flow from UN agencies (US$) in 2012 in Latin America(developing only) to that in Sub-Saharan Africa (developing only)?
Offer a terse response. 0.42. What is the ratio of the Aid flow from UN agencies (US$) of 2009 in Latin America(developing only) to that in World?
Your response must be concise. 0.1. What is the ratio of the Aid flow from UN agencies (US$) of 2010 in Latin America(developing only) to that in World?
Your answer should be compact. 0.1. What is the ratio of the Aid flow from UN agencies (US$) of 2011 in Latin America(developing only) to that in World?
Ensure brevity in your answer.  0.09. What is the ratio of the Aid flow from UN agencies (US$) in 2012 in Latin America(developing only) to that in World?
Offer a very short reply. 0.09. What is the ratio of the Aid flow from UN agencies (US$) of 2009 in Low & middle income to that in Middle income?
Your answer should be compact. 21. What is the ratio of the Aid flow from UN agencies (US$) of 2010 in Low & middle income to that in Middle income?
Offer a terse response. 14.61. What is the ratio of the Aid flow from UN agencies (US$) of 2011 in Low & middle income to that in Middle income?
Offer a terse response. 5.02. What is the ratio of the Aid flow from UN agencies (US$) of 2012 in Low & middle income to that in Middle income?
Give a very brief answer. 4.76. What is the ratio of the Aid flow from UN agencies (US$) of 2009 in Low & middle income to that in Sub-Saharan Africa (all income levels)?
Ensure brevity in your answer.  4.22. What is the ratio of the Aid flow from UN agencies (US$) in 2010 in Low & middle income to that in Sub-Saharan Africa (all income levels)?
Give a very brief answer. 4.08. What is the ratio of the Aid flow from UN agencies (US$) of 2011 in Low & middle income to that in Sub-Saharan Africa (all income levels)?
Make the answer very short. 4.25. What is the ratio of the Aid flow from UN agencies (US$) in 2012 in Low & middle income to that in Sub-Saharan Africa (all income levels)?
Your answer should be very brief. 4.38. What is the ratio of the Aid flow from UN agencies (US$) of 2009 in Low & middle income to that in Sub-Saharan Africa (developing only)?
Provide a succinct answer. 4.22. What is the ratio of the Aid flow from UN agencies (US$) of 2010 in Low & middle income to that in Sub-Saharan Africa (developing only)?
Your response must be concise. 4.08. What is the ratio of the Aid flow from UN agencies (US$) of 2011 in Low & middle income to that in Sub-Saharan Africa (developing only)?
Offer a very short reply. 4.28. What is the ratio of the Aid flow from UN agencies (US$) in 2012 in Low & middle income to that in Sub-Saharan Africa (developing only)?
Make the answer very short. 4.41. What is the ratio of the Aid flow from UN agencies (US$) of 2012 in Low & middle income to that in World?
Provide a succinct answer. 1. What is the ratio of the Aid flow from UN agencies (US$) of 2009 in Middle income to that in Sub-Saharan Africa (all income levels)?
Make the answer very short. 0.2. What is the ratio of the Aid flow from UN agencies (US$) of 2010 in Middle income to that in Sub-Saharan Africa (all income levels)?
Provide a short and direct response. 0.28. What is the ratio of the Aid flow from UN agencies (US$) of 2011 in Middle income to that in Sub-Saharan Africa (all income levels)?
Provide a succinct answer. 0.85. What is the ratio of the Aid flow from UN agencies (US$) of 2012 in Middle income to that in Sub-Saharan Africa (all income levels)?
Your answer should be very brief. 0.92. What is the ratio of the Aid flow from UN agencies (US$) of 2009 in Middle income to that in Sub-Saharan Africa (developing only)?
Provide a short and direct response. 0.2. What is the ratio of the Aid flow from UN agencies (US$) of 2010 in Middle income to that in Sub-Saharan Africa (developing only)?
Offer a very short reply. 0.28. What is the ratio of the Aid flow from UN agencies (US$) in 2011 in Middle income to that in Sub-Saharan Africa (developing only)?
Provide a succinct answer. 0.85. What is the ratio of the Aid flow from UN agencies (US$) of 2012 in Middle income to that in Sub-Saharan Africa (developing only)?
Ensure brevity in your answer.  0.93. What is the ratio of the Aid flow from UN agencies (US$) in 2009 in Middle income to that in World?
Give a very brief answer. 0.05. What is the ratio of the Aid flow from UN agencies (US$) in 2010 in Middle income to that in World?
Your response must be concise. 0.07. What is the ratio of the Aid flow from UN agencies (US$) of 2011 in Middle income to that in World?
Provide a short and direct response. 0.2. What is the ratio of the Aid flow from UN agencies (US$) of 2012 in Middle income to that in World?
Offer a terse response. 0.21. What is the ratio of the Aid flow from UN agencies (US$) in 2009 in Sub-Saharan Africa (all income levels) to that in Sub-Saharan Africa (developing only)?
Offer a terse response. 1. What is the ratio of the Aid flow from UN agencies (US$) in 2010 in Sub-Saharan Africa (all income levels) to that in Sub-Saharan Africa (developing only)?
Provide a short and direct response. 1. What is the ratio of the Aid flow from UN agencies (US$) of 2011 in Sub-Saharan Africa (all income levels) to that in Sub-Saharan Africa (developing only)?
Offer a terse response. 1.01. What is the ratio of the Aid flow from UN agencies (US$) in 2012 in Sub-Saharan Africa (all income levels) to that in Sub-Saharan Africa (developing only)?
Offer a very short reply. 1.01. What is the ratio of the Aid flow from UN agencies (US$) of 2009 in Sub-Saharan Africa (all income levels) to that in World?
Provide a short and direct response. 0.24. What is the ratio of the Aid flow from UN agencies (US$) in 2010 in Sub-Saharan Africa (all income levels) to that in World?
Give a very brief answer. 0.25. What is the ratio of the Aid flow from UN agencies (US$) in 2011 in Sub-Saharan Africa (all income levels) to that in World?
Your response must be concise. 0.23. What is the ratio of the Aid flow from UN agencies (US$) in 2012 in Sub-Saharan Africa (all income levels) to that in World?
Provide a succinct answer. 0.23. What is the ratio of the Aid flow from UN agencies (US$) in 2009 in Sub-Saharan Africa (developing only) to that in World?
Make the answer very short. 0.24. What is the ratio of the Aid flow from UN agencies (US$) in 2010 in Sub-Saharan Africa (developing only) to that in World?
Your answer should be compact. 0.25. What is the ratio of the Aid flow from UN agencies (US$) in 2011 in Sub-Saharan Africa (developing only) to that in World?
Give a very brief answer. 0.23. What is the ratio of the Aid flow from UN agencies (US$) of 2012 in Sub-Saharan Africa (developing only) to that in World?
Offer a terse response. 0.23. What is the difference between the highest and the second highest Aid flow from UN agencies (US$) in 2009?
Make the answer very short. 0. What is the difference between the highest and the second highest Aid flow from UN agencies (US$) of 2010?
Provide a short and direct response. 0. What is the difference between the highest and the second highest Aid flow from UN agencies (US$) in 2011?
Your response must be concise. 6.70e+05. What is the difference between the highest and the second highest Aid flow from UN agencies (US$) in 2012?
Your answer should be compact. 7.20e+05. What is the difference between the highest and the lowest Aid flow from UN agencies (US$) in 2009?
Offer a terse response. 4.16e+08. What is the difference between the highest and the lowest Aid flow from UN agencies (US$) of 2010?
Provide a succinct answer. 3.41e+08. What is the difference between the highest and the lowest Aid flow from UN agencies (US$) in 2011?
Offer a terse response. 4.13e+08. What is the difference between the highest and the lowest Aid flow from UN agencies (US$) in 2012?
Make the answer very short. 3.59e+08. 